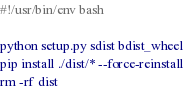<code> <loc_0><loc_0><loc_500><loc_500><_Bash_>#!/usr/bin/env bash

python setup.py sdist bdist_wheel
pip install ./dist/* --force-reinstall
rm -rf dist</code> 